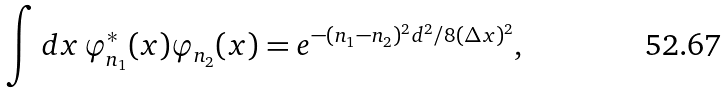Convert formula to latex. <formula><loc_0><loc_0><loc_500><loc_500>\int d x \, \varphi _ { n _ { 1 } } ^ { * } ( x ) \varphi _ { n _ { 2 } } ( x ) = e ^ { - ( n _ { 1 } - n _ { 2 } ) ^ { 2 } d ^ { 2 } / 8 ( \Delta x ) ^ { 2 } } ,</formula> 